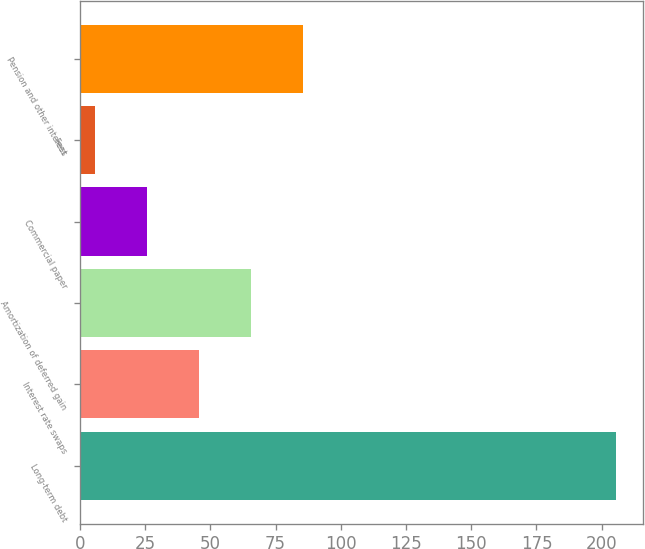<chart> <loc_0><loc_0><loc_500><loc_500><bar_chart><fcel>Long-term debt<fcel>Interest rate swaps<fcel>Amortization of deferred gain<fcel>Commercial paper<fcel>Fees<fcel>Pension and other interest<nl><fcel>205.5<fcel>45.58<fcel>65.57<fcel>25.59<fcel>5.6<fcel>85.56<nl></chart> 